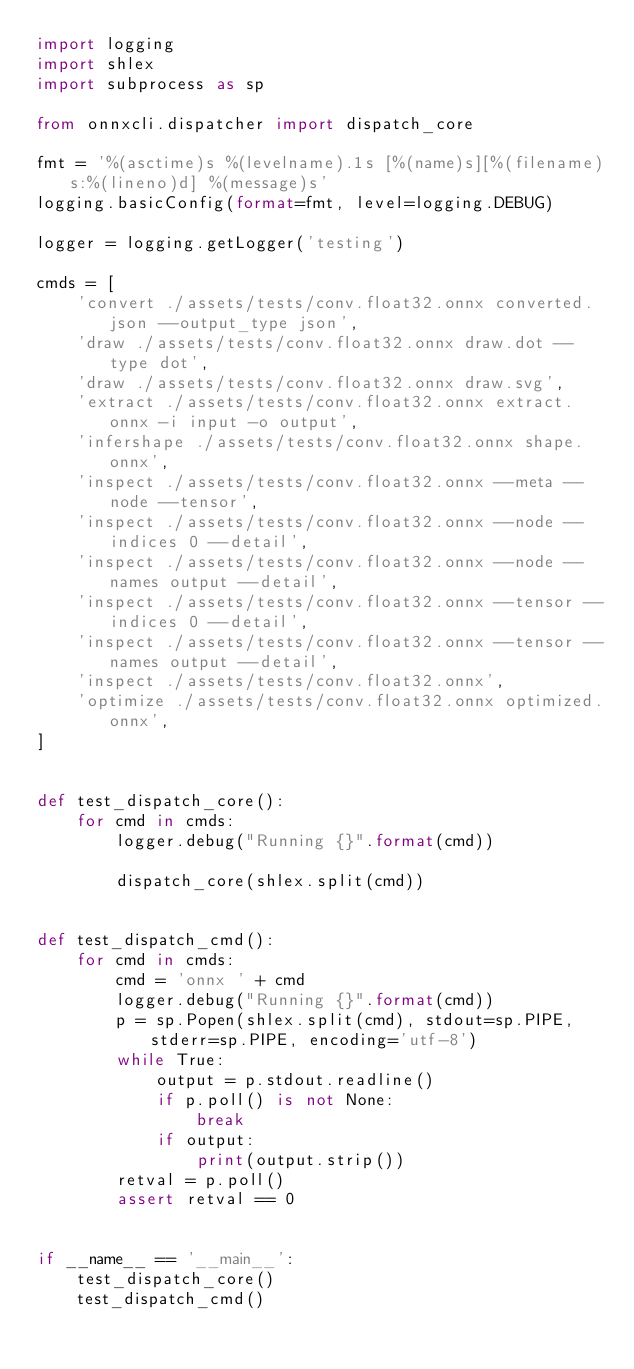Convert code to text. <code><loc_0><loc_0><loc_500><loc_500><_Python_>import logging
import shlex
import subprocess as sp

from onnxcli.dispatcher import dispatch_core

fmt = '%(asctime)s %(levelname).1s [%(name)s][%(filename)s:%(lineno)d] %(message)s'
logging.basicConfig(format=fmt, level=logging.DEBUG)

logger = logging.getLogger('testing')

cmds = [
    'convert ./assets/tests/conv.float32.onnx converted.json --output_type json',
    'draw ./assets/tests/conv.float32.onnx draw.dot --type dot',
    'draw ./assets/tests/conv.float32.onnx draw.svg',
    'extract ./assets/tests/conv.float32.onnx extract.onnx -i input -o output',
    'infershape ./assets/tests/conv.float32.onnx shape.onnx',
    'inspect ./assets/tests/conv.float32.onnx --meta --node --tensor',
    'inspect ./assets/tests/conv.float32.onnx --node --indices 0 --detail',
    'inspect ./assets/tests/conv.float32.onnx --node --names output --detail',
    'inspect ./assets/tests/conv.float32.onnx --tensor --indices 0 --detail',
    'inspect ./assets/tests/conv.float32.onnx --tensor --names output --detail',
    'inspect ./assets/tests/conv.float32.onnx',
    'optimize ./assets/tests/conv.float32.onnx optimized.onnx',
]


def test_dispatch_core():
    for cmd in cmds:
        logger.debug("Running {}".format(cmd))

        dispatch_core(shlex.split(cmd))


def test_dispatch_cmd():
    for cmd in cmds:
        cmd = 'onnx ' + cmd
        logger.debug("Running {}".format(cmd))
        p = sp.Popen(shlex.split(cmd), stdout=sp.PIPE, stderr=sp.PIPE, encoding='utf-8')
        while True:
            output = p.stdout.readline()
            if p.poll() is not None:
                break
            if output:
                print(output.strip())
        retval = p.poll()
        assert retval == 0


if __name__ == '__main__':
    test_dispatch_core()
    test_dispatch_cmd()
</code> 